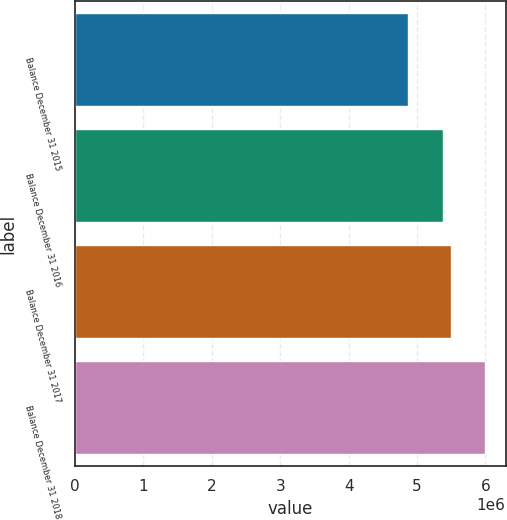<chart> <loc_0><loc_0><loc_500><loc_500><bar_chart><fcel>Balance December 31 2015<fcel>Balance December 31 2016<fcel>Balance December 31 2017<fcel>Balance December 31 2018<nl><fcel>4.86357e+06<fcel>5.38507e+06<fcel>5.49823e+06<fcel>5.9952e+06<nl></chart> 